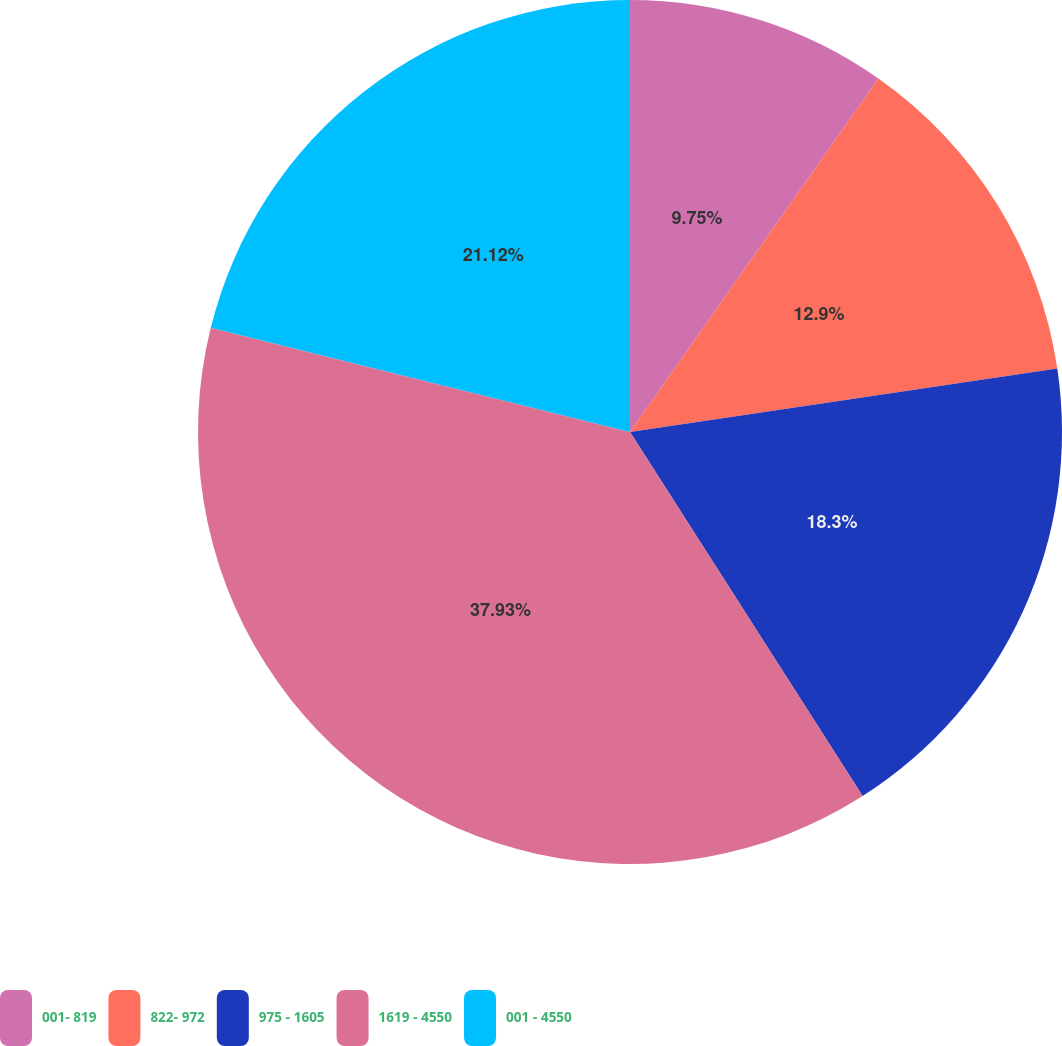Convert chart. <chart><loc_0><loc_0><loc_500><loc_500><pie_chart><fcel>001- 819<fcel>822- 972<fcel>975 - 1605<fcel>1619 - 4550<fcel>001 - 4550<nl><fcel>9.75%<fcel>12.9%<fcel>18.3%<fcel>37.93%<fcel>21.12%<nl></chart> 